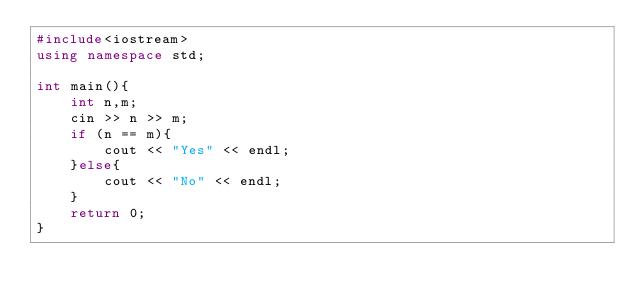Convert code to text. <code><loc_0><loc_0><loc_500><loc_500><_C++_>#include<iostream>
using namespace std;

int main(){
    int n,m;
    cin >> n >> m;
    if (n == m){
        cout << "Yes" << endl;
    }else{
        cout << "No" << endl;
    }
    return 0;
}</code> 